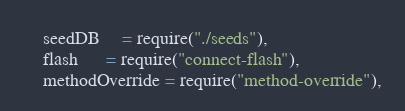<code> <loc_0><loc_0><loc_500><loc_500><_JavaScript_>	seedDB     = require("./seeds"),
	flash      = require("connect-flash"),
	methodOverride = require("method-override"),</code> 